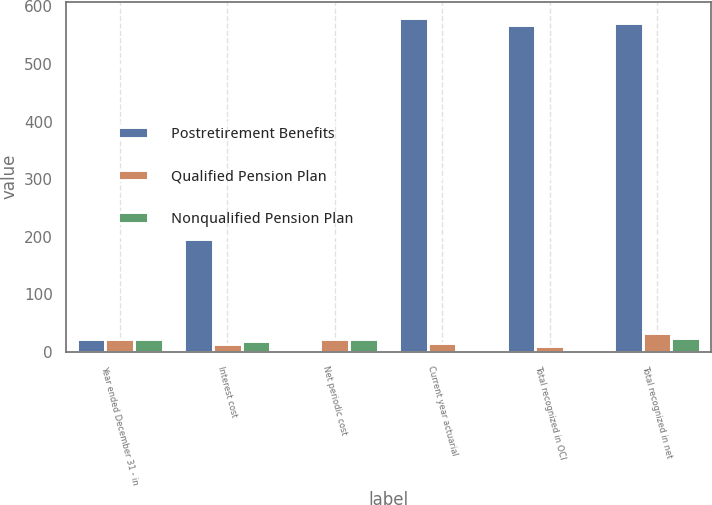<chart> <loc_0><loc_0><loc_500><loc_500><stacked_bar_chart><ecel><fcel>Year ended December 31 - in<fcel>Interest cost<fcel>Net periodic cost<fcel>Current year actuarial<fcel>Total recognized in OCI<fcel>Total recognized in net<nl><fcel>Postretirement Benefits<fcel>22<fcel>196<fcel>3<fcel>579<fcel>568<fcel>571<nl><fcel>Qualified Pension Plan<fcel>22<fcel>13<fcel>22<fcel>15<fcel>10<fcel>32<nl><fcel>Nonqualified Pension Plan<fcel>22<fcel>19<fcel>23<fcel>1<fcel>1<fcel>24<nl></chart> 